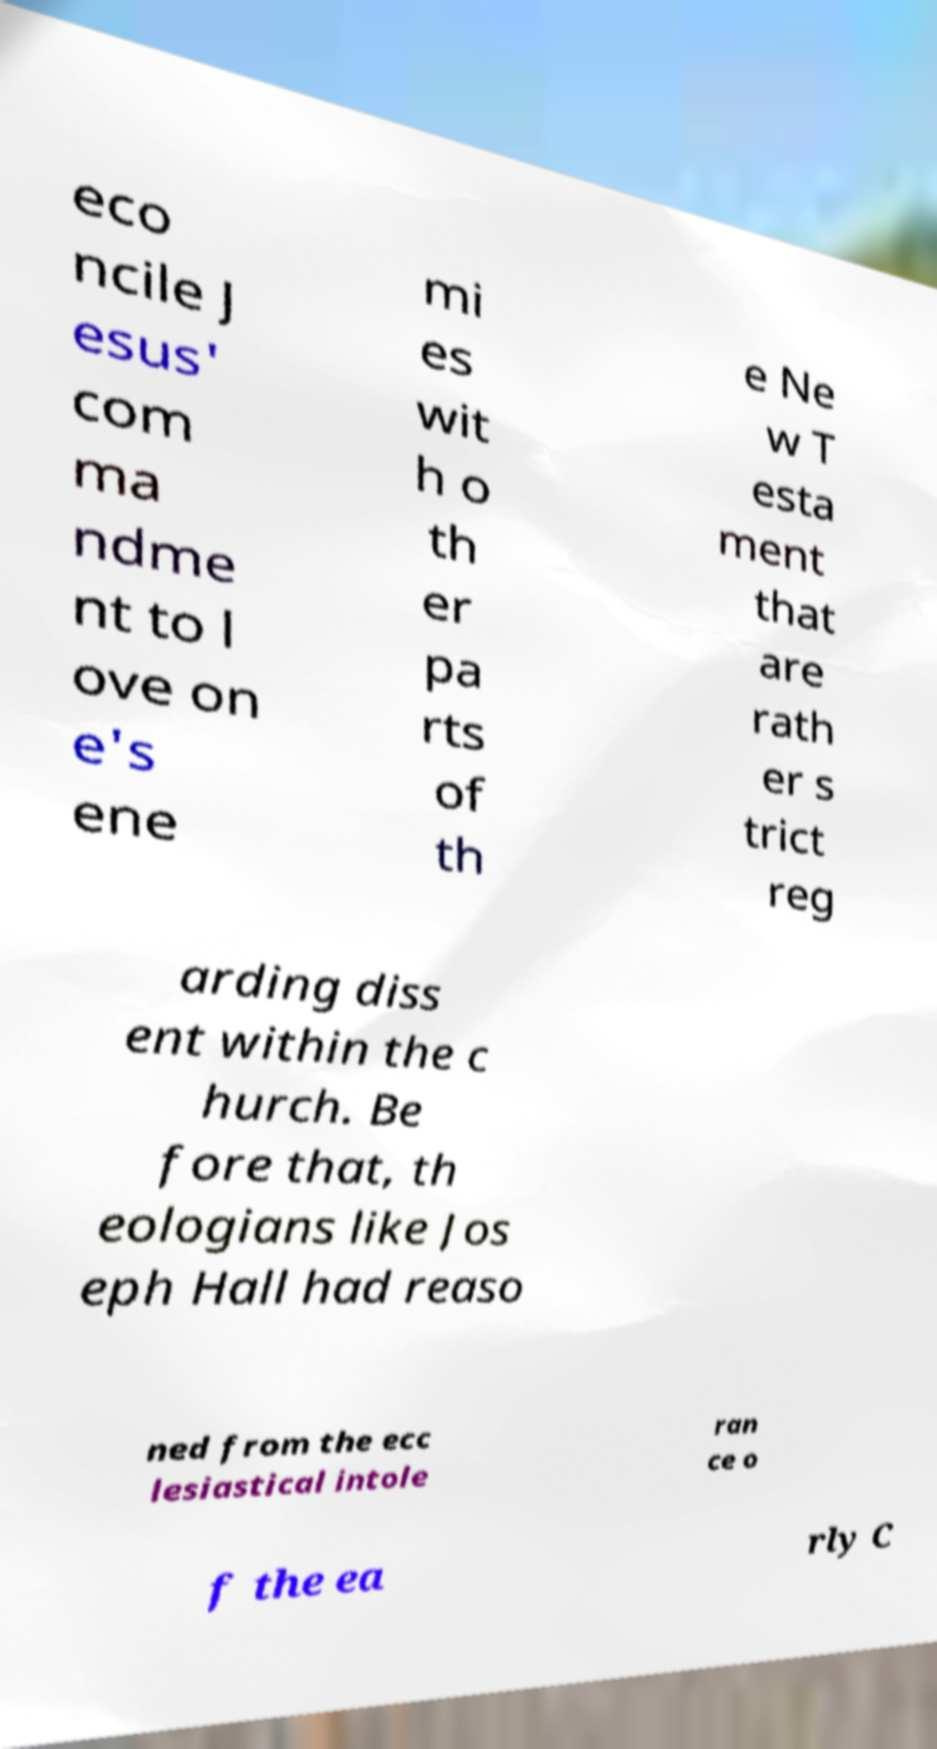Can you read and provide the text displayed in the image?This photo seems to have some interesting text. Can you extract and type it out for me? eco ncile J esus' com ma ndme nt to l ove on e's ene mi es wit h o th er pa rts of th e Ne w T esta ment that are rath er s trict reg arding diss ent within the c hurch. Be fore that, th eologians like Jos eph Hall had reaso ned from the ecc lesiastical intole ran ce o f the ea rly C 